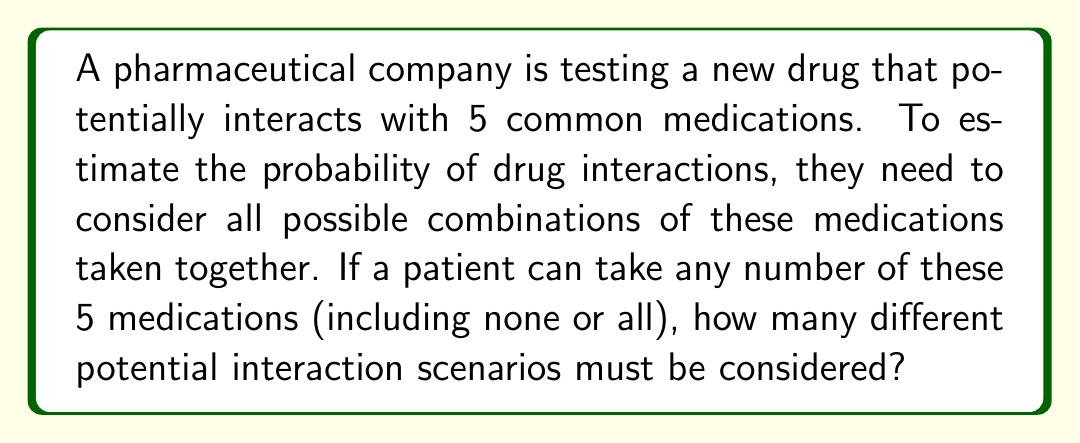Solve this math problem. Let's approach this step-by-step:

1) This problem is essentially asking for the number of subsets of a set with 5 elements.

2) For each medication, we have two choices: either it's taken or it's not.

3) We can represent this as a binary choice for each medication:
   Medication 1: 0 or 1
   Medication 2: 0 or 1
   Medication 3: 0 or 1
   Medication 4: 0 or 1
   Medication 5: 0 or 1

   Where 0 means not taking the medication and 1 means taking it.

4) This is equivalent to finding the number of ways to fill 5 positions with either 0 or 1.

5) For each position, we have 2 choices. And we have 5 positions.

6) Using the multiplication principle, the total number of possibilities is:

   $$ 2 \times 2 \times 2 \times 2 \times 2 = 2^5 $$

7) We can calculate this:

   $$ 2^5 = 32 $$

Therefore, there are 32 different potential interaction scenarios to consider.
Answer: 32 